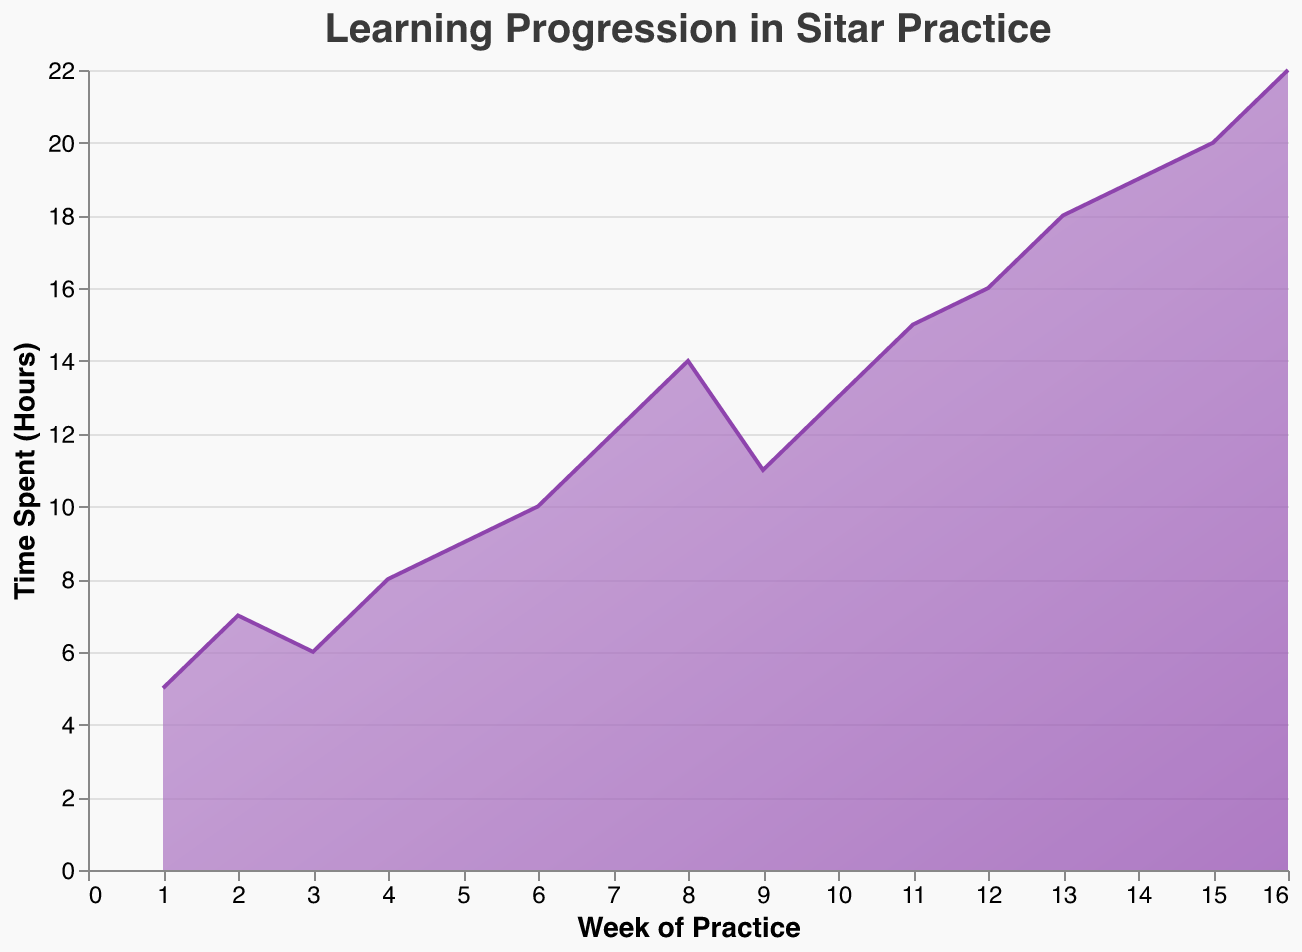What is the title of the figure? The title of the figure is usually found at the top and describes the main theme or data represented in the chart. In this case, the title is "Learning Progression in Sitar Practice".
Answer: Learning Progression in Sitar Practice What are the axes' titles? Axes' titles are typically labeled along the x-axis and y-axis to describe what each axis represents. In this figure, the x-axis title is "Week of Practice" and the y-axis title is "Time Spent (Hours)".
Answer: Week of Practice, Time Spent (Hours) In which week was the highest practice time recorded? To determine the week with the highest practice time, you need to identify the peak value on the y-axis. The highest recorded time is 22 hours in Week 16.
Answer: Week 16 Compare the practice time between Week 5 and Week 10. Which week had more practice time and by how much? Week 5 had 9 hours of practice and Week 10 had 13 hours of practice. Comparing these values, Week 10 had more practice time. The difference is 13 - 9 = 4 hours.
Answer: Week 10 by 4 hours What new technique was mastered in Week 7? The tooltip in the plot typically shows specific information about each data point, including technique names. For Week 7, the new technique mastered was "Improvisation in Raag Yaman".
Answer: Improvisation in Raag Yaman Calculate the average practice time spent over the first 8 weeks. To find the average practice time, sum the practice times from Week 1 to Week 8 and divide by 8. The total is (5 + 7 + 6 + 8 + 9 + 10 + 12 + 14) = 71 hours. The average is 71 / 8 = 8.875 hours.
Answer: 8.875 hours What is the color gradient used in the chart? The color gradient in the chart transitions from a darker color (#8e44ad) at the bottom to a lighter color (#c39bd3) at the top, creating a visually appealing effect.
Answer: Darker at the bottom to lighter at the top How did the practice time trend over the first 4 weeks? Observing the values from Week 1 to Week 4, the practice time increased from 5 hours to 7 hours, slightly dropped to 6 hours in Week 3, and then rose to 8 hours in Week 4, showing a general upward trend with minor fluctuation.
Answer: Increasing with minor fluctuation Which week had the smallest increase in practice time compared to the previous week? By examining the differences between consecutive weeks, we see the smallest increase was from Week 2 to Week 3 (7 to 6 hours, which is actually a decrease of 1 hour).
Answer: Week 3 What is the total practice time spent from Week 13 to Week 15? Summing the practice times from Week 13 to Week 15 gives (18 + 19 + 20) = 57 hours.
Answer: 57 hours 